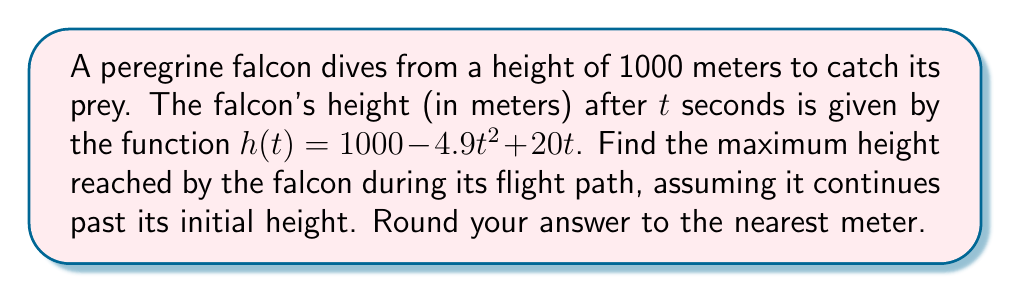Give your solution to this math problem. To find the maximum height, we need to follow these steps:

1) First, we need to find the critical points of the function $h(t)$. To do this, we take the derivative of $h(t)$ and set it equal to zero:

   $h'(t) = -9.8t + 20$
   
   Set $h'(t) = 0$:
   $-9.8t + 20 = 0$
   $-9.8t = -20$
   $t = \frac{20}{9.8} \approx 2.04$ seconds

2) We also need to consider the endpoints of the domain. In this case, the falcon starts at $t=0$, but there's no upper limit specified for $t$. So we'll only consider $t=0$ as an additional point to check.

3) Now, we evaluate $h(t)$ at $t=0$ and $t=2.04$:

   At $t=0$: $h(0) = 1000 - 4.9(0)^2 + 20(0) = 1000$ meters
   
   At $t=2.04$: 
   $h(2.04) = 1000 - 4.9(2.04)^2 + 20(2.04)$
   $= 1000 - 4.9(4.1616) + 40.8$
   $= 1000 - 20.39184 + 40.8$
   $\approx 1020.41$ meters

4) The maximum height is the larger of these two values, which is approximately 1020.41 meters.

5) Rounding to the nearest meter, we get 1020 meters.
Answer: 1020 meters 